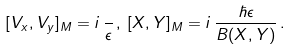Convert formula to latex. <formula><loc_0><loc_0><loc_500><loc_500>[ V _ { x } , V _ { y } ] _ { M } = i \, \frac { } { \epsilon } \, , \, [ X , Y ] _ { M } = i \, \frac { \hbar { \epsilon } } { B ( X , Y ) } \, .</formula> 